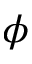<formula> <loc_0><loc_0><loc_500><loc_500>\phi</formula> 